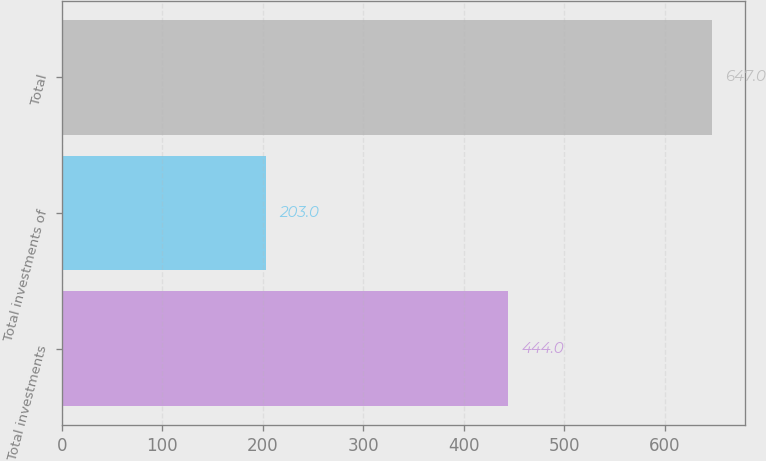Convert chart to OTSL. <chart><loc_0><loc_0><loc_500><loc_500><bar_chart><fcel>Total investments<fcel>Total investments of<fcel>Total<nl><fcel>444<fcel>203<fcel>647<nl></chart> 